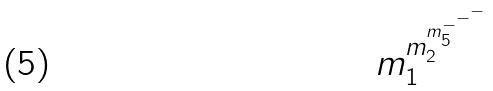<formula> <loc_0><loc_0><loc_500><loc_500>m _ { 1 } ^ { m _ { 2 } ^ { m _ { 5 } ^ { - ^ { - ^ { - } } } } }</formula> 